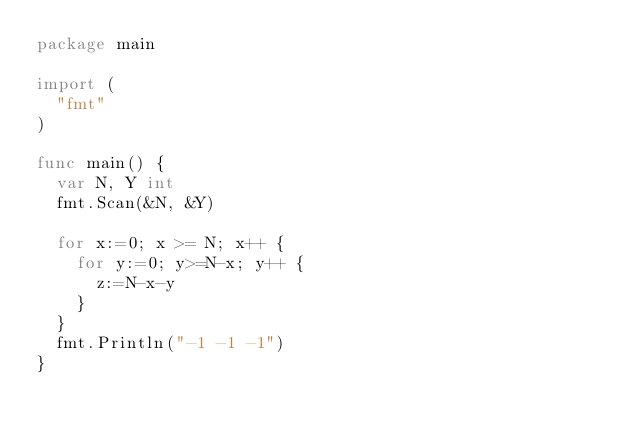Convert code to text. <code><loc_0><loc_0><loc_500><loc_500><_Go_>package main

import (
	"fmt"
)

func main() {
	var N, Y int
	fmt.Scan(&N, &Y)

	for x:=0; x >= N; x++ {
		for y:=0; y>=N-x; y++ {
			z:=N-x-y
		}  
	}
	fmt.Println("-1 -1 -1") 
}</code> 